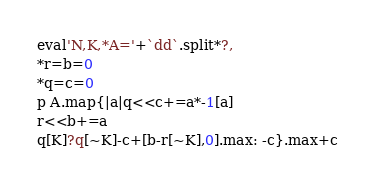<code> <loc_0><loc_0><loc_500><loc_500><_Ruby_>eval'N,K,*A='+`dd`.split*?,
*r=b=0
*q=c=0
p A.map{|a|q<<c+=a*-1[a]
r<<b+=a
q[K]?q[~K]-c+[b-r[~K],0].max: -c}.max+c</code> 